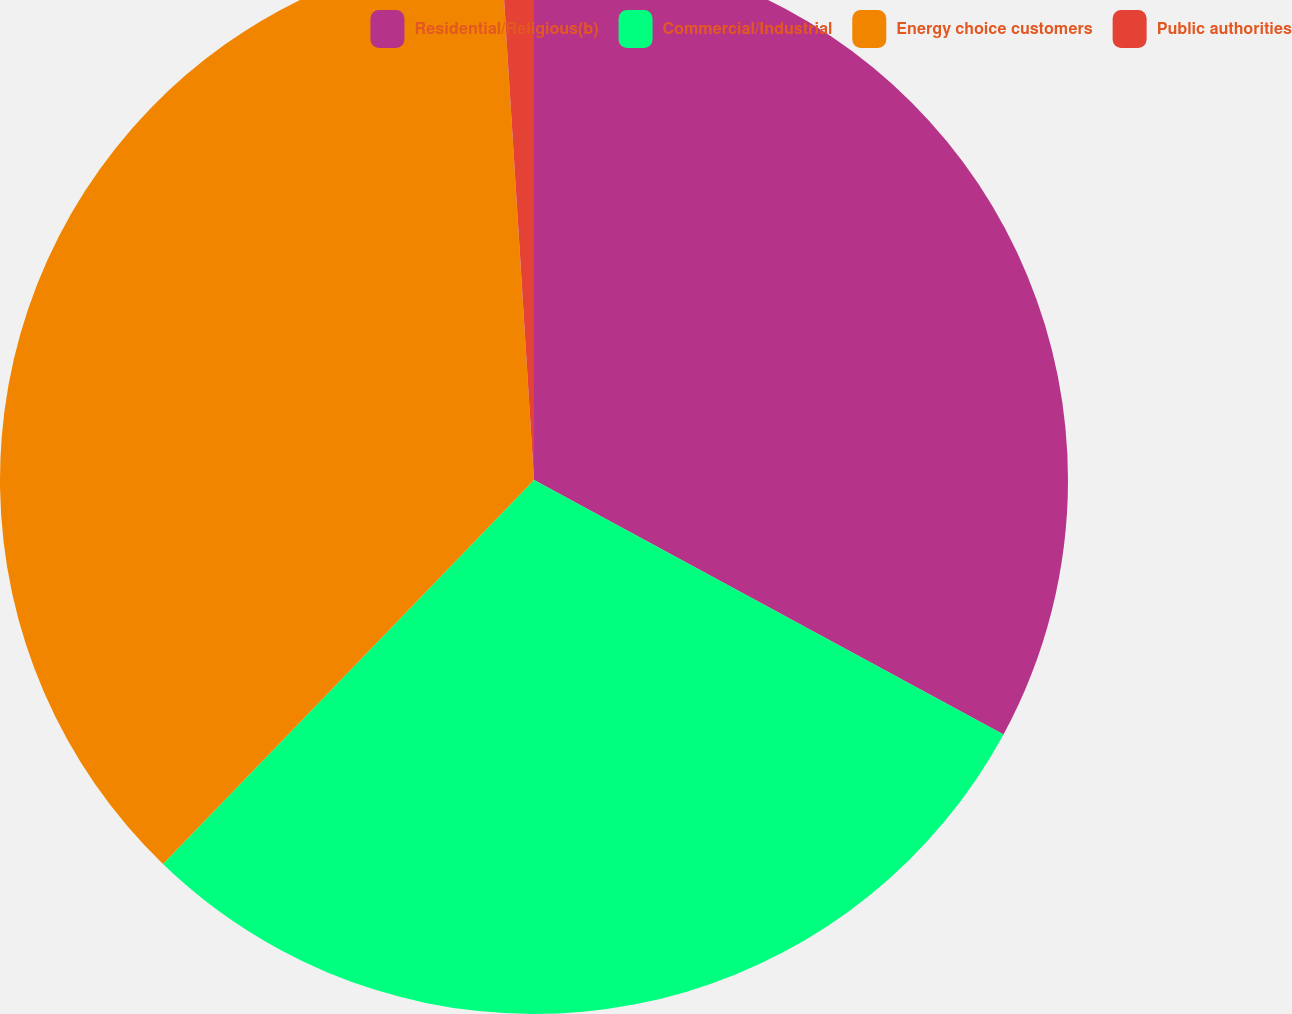Convert chart. <chart><loc_0><loc_0><loc_500><loc_500><pie_chart><fcel>Residential/Religious(b)<fcel>Commercial/Industrial<fcel>Energy choice customers<fcel>Public authorities<nl><fcel>32.9%<fcel>29.32%<fcel>36.78%<fcel>0.99%<nl></chart> 